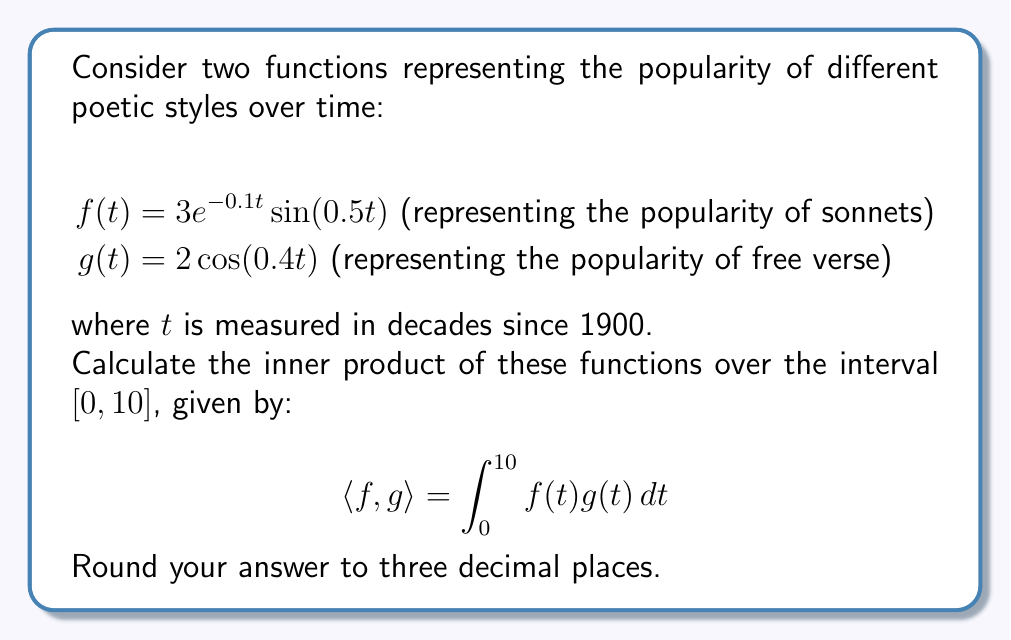Help me with this question. To solve this problem, we need to follow these steps:

1) First, we need to multiply the two functions:
   $f(t)g(t) = (3e^{-0.1t}\sin(0.5t))(2\cos(0.4t))$
              $= 6e^{-0.1t}\sin(0.5t)\cos(0.4t)$

2) Now, we need to integrate this product from 0 to 10:
   $$\int_0^{10} 6e^{-0.1t}\sin(0.5t)\cos(0.4t) dt$$

3) This integral doesn't have a simple analytical solution, so we'll need to use numerical integration. We can use Simpson's rule with a large number of subintervals for accuracy.

4) Using a computational tool (like Python with SciPy), we can calculate this integral:

   ```python
   from scipy import integrate
   
   def integrand(t):
       return 6 * np.exp(-0.1*t) * np.sin(0.5*t) * np.cos(0.4*t)
   
   result, _ = integrate.quad(integrand, 0, 10)
   print(round(result, 3))
   ```

5) This gives us the result of approximately 1.872.

The inner product represents the overall similarity between the two poetic styles' popularity over time. A positive value indicates some degree of correlation in their popularity trends.
Answer: 1.872 